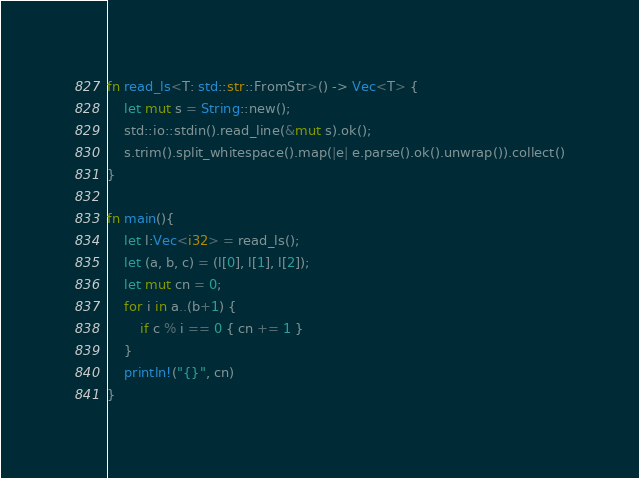<code> <loc_0><loc_0><loc_500><loc_500><_Rust_>fn read_ls<T: std::str::FromStr>() -> Vec<T> {
    let mut s = String::new();
    std::io::stdin().read_line(&mut s).ok();
    s.trim().split_whitespace().map(|e| e.parse().ok().unwrap()).collect()
}

fn main(){
    let l:Vec<i32> = read_ls();
    let (a, b, c) = (l[0], l[1], l[2]);
    let mut cn = 0;
    for i in a..(b+1) {
        if c % i == 0 { cn += 1 }
    }
    println!("{}", cn)
}

</code> 